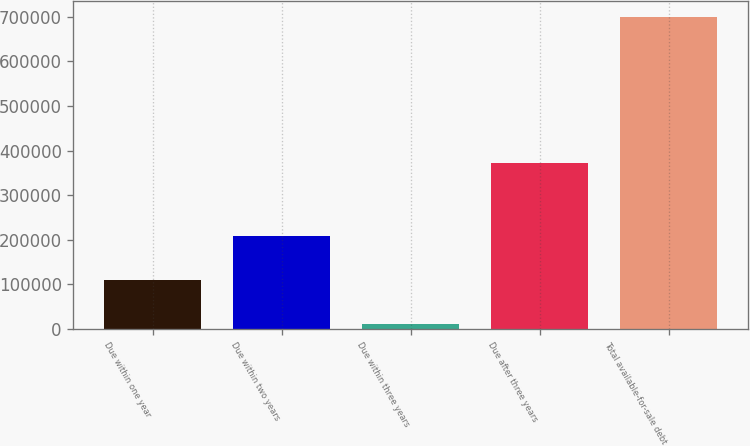<chart> <loc_0><loc_0><loc_500><loc_500><bar_chart><fcel>Due within one year<fcel>Due within two years<fcel>Due within three years<fcel>Due after three years<fcel>Total available-for-sale debt<nl><fcel>109562<fcel>208144<fcel>10402<fcel>371710<fcel>699818<nl></chart> 